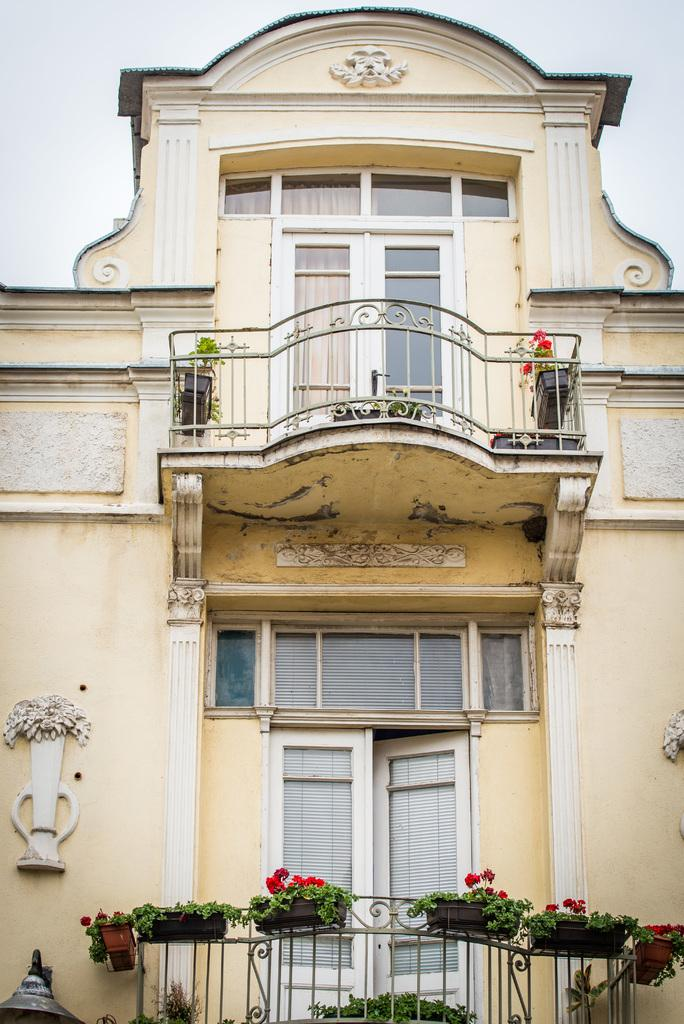What is the main structure visible in the image? There is a building in the image. Are there any decorative elements on the building? Yes, there are potted plants on the building. What type of cloud can be seen burning in the image? There is no cloud present in the image, and therefore no cloud can be seen burning. 